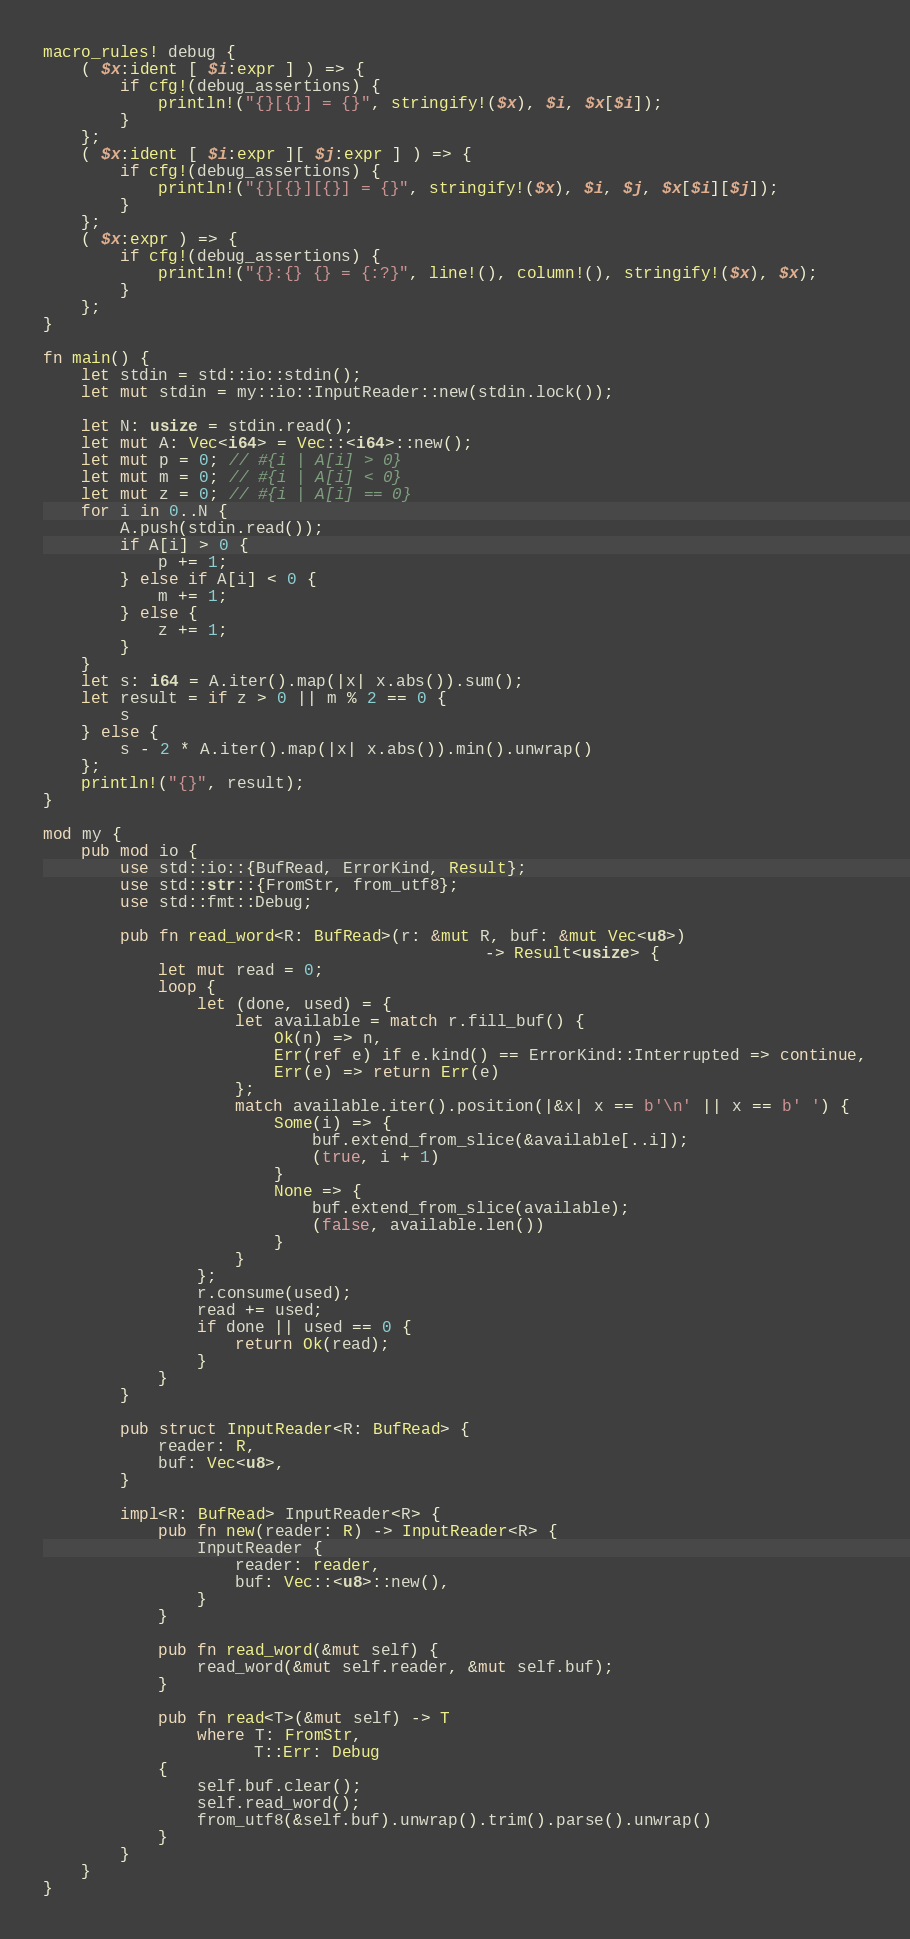<code> <loc_0><loc_0><loc_500><loc_500><_Rust_>macro_rules! debug {
    ( $x:ident [ $i:expr ] ) => {
        if cfg!(debug_assertions) {
            println!("{}[{}] = {}", stringify!($x), $i, $x[$i]);
        }
    };
    ( $x:ident [ $i:expr ][ $j:expr ] ) => {
        if cfg!(debug_assertions) {
            println!("{}[{}][{}] = {}", stringify!($x), $i, $j, $x[$i][$j]);
        }
    };
    ( $x:expr ) => {
        if cfg!(debug_assertions) {
            println!("{}:{} {} = {:?}", line!(), column!(), stringify!($x), $x);
        }
    };
}

fn main() {
    let stdin = std::io::stdin();
    let mut stdin = my::io::InputReader::new(stdin.lock());

    let N: usize = stdin.read();
    let mut A: Vec<i64> = Vec::<i64>::new();
    let mut p = 0; // #{i | A[i] > 0}
    let mut m = 0; // #{i | A[i] < 0} 
    let mut z = 0; // #{i | A[i] == 0}
    for i in 0..N {
        A.push(stdin.read());
        if A[i] > 0 {
            p += 1;
        } else if A[i] < 0 {
            m += 1;
        } else {
            z += 1;
        }
    }
    let s: i64 = A.iter().map(|x| x.abs()).sum();
    let result = if z > 0 || m % 2 == 0 {
        s
    } else {
        s - 2 * A.iter().map(|x| x.abs()).min().unwrap()
    };
    println!("{}", result);
}

mod my {
    pub mod io {
        use std::io::{BufRead, ErrorKind, Result};
        use std::str::{FromStr, from_utf8};
        use std::fmt::Debug;

        pub fn read_word<R: BufRead>(r: &mut R, buf: &mut Vec<u8>)
                                              -> Result<usize> {
            let mut read = 0;
            loop {
                let (done, used) = {
                    let available = match r.fill_buf() {
                        Ok(n) => n,
                        Err(ref e) if e.kind() == ErrorKind::Interrupted => continue,
                        Err(e) => return Err(e)
                    };
                    match available.iter().position(|&x| x == b'\n' || x == b' ') {
                        Some(i) => {
                            buf.extend_from_slice(&available[..i]);
                            (true, i + 1)
                        }
                        None => {
                            buf.extend_from_slice(available);
                            (false, available.len())
                        }
                    }
                };
                r.consume(used);
                read += used;
                if done || used == 0 {
                    return Ok(read);
                }
            }
        }

        pub struct InputReader<R: BufRead> {
            reader: R,
            buf: Vec<u8>,
        }

        impl<R: BufRead> InputReader<R> {
            pub fn new(reader: R) -> InputReader<R> {
                InputReader {
                    reader: reader,
                    buf: Vec::<u8>::new(),
                }
            }

            pub fn read_word(&mut self) {
                read_word(&mut self.reader, &mut self.buf);
            }
            
            pub fn read<T>(&mut self) -> T
                where T: FromStr,
                      T::Err: Debug
            {
                self.buf.clear();
                self.read_word();
                from_utf8(&self.buf).unwrap().trim().parse().unwrap()
            }
        }
    }
}</code> 